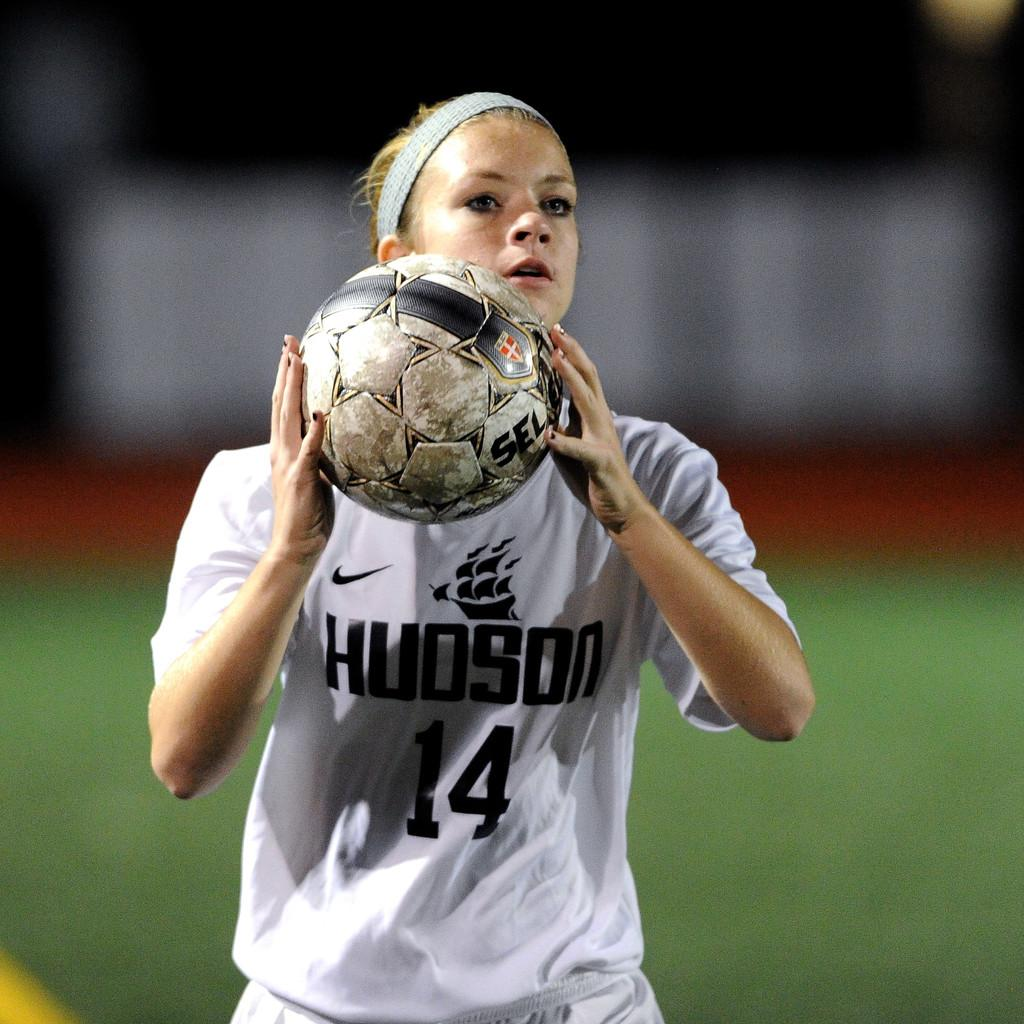Provide a one-sentence caption for the provided image. a sports woman in a Hudson 14 jersey holds a soccer ball. 